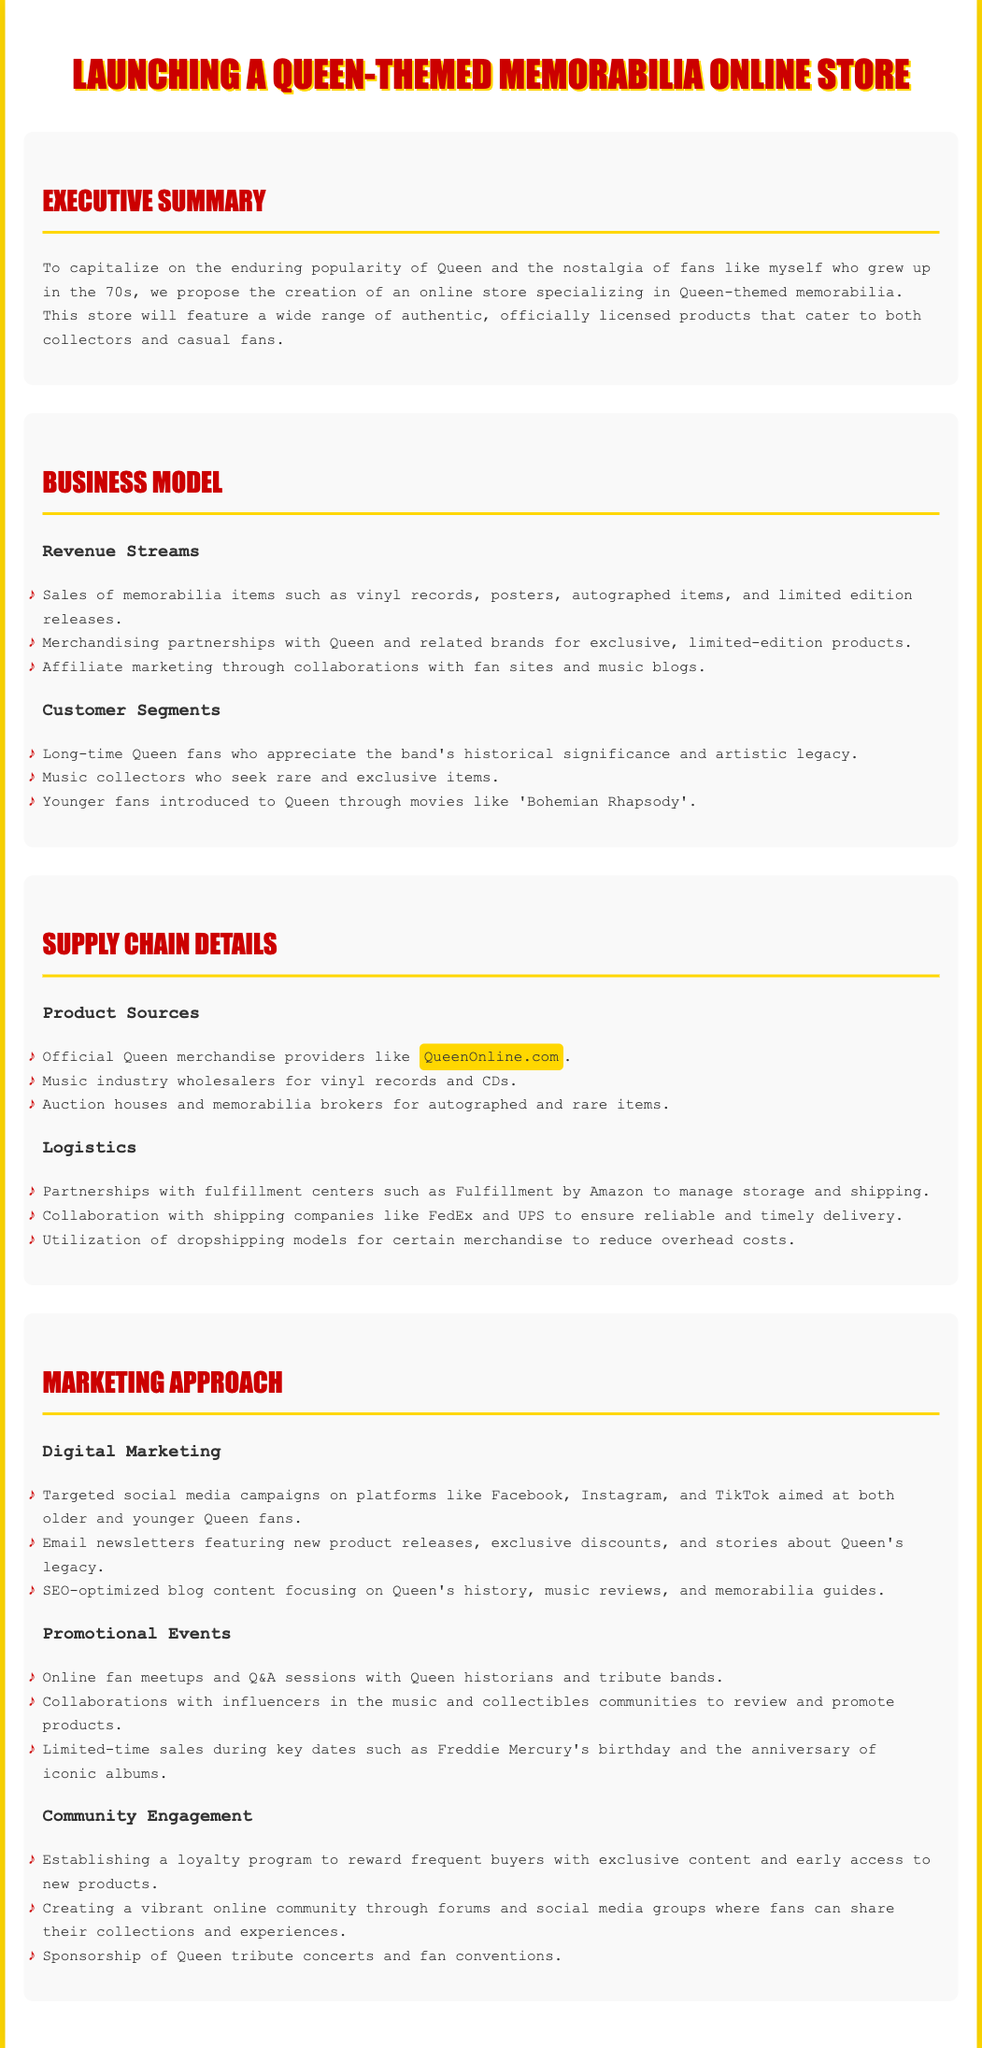What is the primary goal of the proposal? The primary goal is to capitalize on the enduring popularity of Queen and the nostalgia of fans like myself who grew up in the 70s.
Answer: Capitalize on popularity What types of products will the store sell? The document specifies sales of memorabilia items such as vinyl records, posters, autographed items, and limited edition releases.
Answer: Memorabilia items What is one key partnership mentioned for logistics? The proposal mentions partnerships with fulfillment centers such as Fulfillment by Amazon to manage storage and shipping.
Answer: Fulfillment by Amazon Who are the target customer segments? The document lists long-time Queen fans, music collectors, and younger fans as target customer segments.
Answer: Long-time Queen fans, music collectors, younger fans What marketing strategy involves online events? The proposal mentions online fan meetups and Q&A sessions with Queen historians and tribute bands as part of the marketing strategy.
Answer: Online fan meetups What is one revenue stream for the online store? One revenue stream mentioned is merchandising partnerships with Queen and related brands for exclusive, limited-edition products.
Answer: Merchandising partnerships What kind of community engagement activities are proposed? The document includes establishing a loyalty program to reward frequent buyers as a community engagement activity.
Answer: Loyalty program Which social media platforms will be utilized for targeted campaigns? The proposal states that targeted social media campaigns will be on Facebook, Instagram, and TikTok.
Answer: Facebook, Instagram, TikTok What type of product sources does the proposal include? The proposal refers to official Queen merchandise providers like QueenOnline.com as product sources.
Answer: QueenOnline.com 